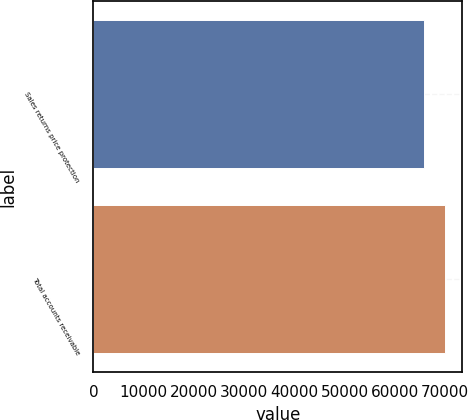Convert chart. <chart><loc_0><loc_0><loc_500><loc_500><bar_chart><fcel>Sales returns price protection<fcel>Total accounts receivable<nl><fcel>65785<fcel>69904<nl></chart> 